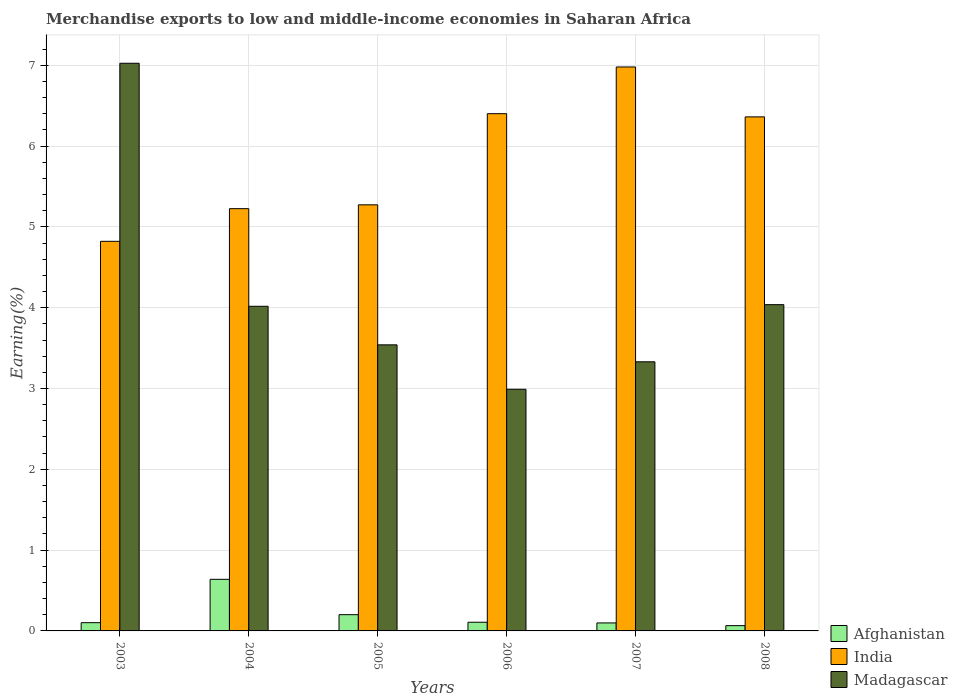How many different coloured bars are there?
Ensure brevity in your answer.  3. How many groups of bars are there?
Make the answer very short. 6. How many bars are there on the 2nd tick from the left?
Offer a terse response. 3. What is the label of the 6th group of bars from the left?
Your answer should be compact. 2008. What is the percentage of amount earned from merchandise exports in Afghanistan in 2007?
Provide a succinct answer. 0.1. Across all years, what is the maximum percentage of amount earned from merchandise exports in Afghanistan?
Give a very brief answer. 0.64. Across all years, what is the minimum percentage of amount earned from merchandise exports in Afghanistan?
Offer a very short reply. 0.07. In which year was the percentage of amount earned from merchandise exports in India maximum?
Give a very brief answer. 2007. In which year was the percentage of amount earned from merchandise exports in Afghanistan minimum?
Provide a succinct answer. 2008. What is the total percentage of amount earned from merchandise exports in Madagascar in the graph?
Provide a succinct answer. 24.94. What is the difference between the percentage of amount earned from merchandise exports in Madagascar in 2006 and that in 2007?
Offer a terse response. -0.34. What is the difference between the percentage of amount earned from merchandise exports in Madagascar in 2007 and the percentage of amount earned from merchandise exports in Afghanistan in 2004?
Your answer should be compact. 2.69. What is the average percentage of amount earned from merchandise exports in Madagascar per year?
Offer a terse response. 4.16. In the year 2007, what is the difference between the percentage of amount earned from merchandise exports in India and percentage of amount earned from merchandise exports in Madagascar?
Keep it short and to the point. 3.65. In how many years, is the percentage of amount earned from merchandise exports in Afghanistan greater than 6 %?
Make the answer very short. 0. What is the ratio of the percentage of amount earned from merchandise exports in Afghanistan in 2004 to that in 2008?
Make the answer very short. 9.75. Is the percentage of amount earned from merchandise exports in India in 2007 less than that in 2008?
Your response must be concise. No. Is the difference between the percentage of amount earned from merchandise exports in India in 2003 and 2007 greater than the difference between the percentage of amount earned from merchandise exports in Madagascar in 2003 and 2007?
Make the answer very short. No. What is the difference between the highest and the second highest percentage of amount earned from merchandise exports in Madagascar?
Your response must be concise. 2.99. What is the difference between the highest and the lowest percentage of amount earned from merchandise exports in India?
Provide a short and direct response. 2.16. In how many years, is the percentage of amount earned from merchandise exports in Madagascar greater than the average percentage of amount earned from merchandise exports in Madagascar taken over all years?
Offer a very short reply. 1. How many bars are there?
Provide a short and direct response. 18. Are all the bars in the graph horizontal?
Ensure brevity in your answer.  No. How many legend labels are there?
Make the answer very short. 3. How are the legend labels stacked?
Keep it short and to the point. Vertical. What is the title of the graph?
Your response must be concise. Merchandise exports to low and middle-income economies in Saharan Africa. Does "Tonga" appear as one of the legend labels in the graph?
Offer a very short reply. No. What is the label or title of the Y-axis?
Your answer should be very brief. Earning(%). What is the Earning(%) in Afghanistan in 2003?
Give a very brief answer. 0.1. What is the Earning(%) of India in 2003?
Provide a short and direct response. 4.82. What is the Earning(%) of Madagascar in 2003?
Make the answer very short. 7.02. What is the Earning(%) in Afghanistan in 2004?
Your response must be concise. 0.64. What is the Earning(%) of India in 2004?
Provide a succinct answer. 5.23. What is the Earning(%) in Madagascar in 2004?
Make the answer very short. 4.02. What is the Earning(%) in Afghanistan in 2005?
Offer a very short reply. 0.2. What is the Earning(%) of India in 2005?
Provide a short and direct response. 5.27. What is the Earning(%) of Madagascar in 2005?
Your answer should be compact. 3.54. What is the Earning(%) of Afghanistan in 2006?
Make the answer very short. 0.11. What is the Earning(%) in India in 2006?
Offer a very short reply. 6.4. What is the Earning(%) in Madagascar in 2006?
Keep it short and to the point. 2.99. What is the Earning(%) in Afghanistan in 2007?
Offer a terse response. 0.1. What is the Earning(%) of India in 2007?
Your answer should be compact. 6.98. What is the Earning(%) of Madagascar in 2007?
Your answer should be compact. 3.33. What is the Earning(%) in Afghanistan in 2008?
Offer a terse response. 0.07. What is the Earning(%) of India in 2008?
Offer a very short reply. 6.36. What is the Earning(%) in Madagascar in 2008?
Your response must be concise. 4.04. Across all years, what is the maximum Earning(%) in Afghanistan?
Make the answer very short. 0.64. Across all years, what is the maximum Earning(%) of India?
Keep it short and to the point. 6.98. Across all years, what is the maximum Earning(%) in Madagascar?
Offer a very short reply. 7.02. Across all years, what is the minimum Earning(%) of Afghanistan?
Keep it short and to the point. 0.07. Across all years, what is the minimum Earning(%) in India?
Make the answer very short. 4.82. Across all years, what is the minimum Earning(%) of Madagascar?
Your response must be concise. 2.99. What is the total Earning(%) of Afghanistan in the graph?
Your answer should be very brief. 1.21. What is the total Earning(%) of India in the graph?
Give a very brief answer. 35.06. What is the total Earning(%) in Madagascar in the graph?
Your response must be concise. 24.94. What is the difference between the Earning(%) in Afghanistan in 2003 and that in 2004?
Offer a very short reply. -0.54. What is the difference between the Earning(%) in India in 2003 and that in 2004?
Your response must be concise. -0.4. What is the difference between the Earning(%) in Madagascar in 2003 and that in 2004?
Provide a succinct answer. 3.01. What is the difference between the Earning(%) of Afghanistan in 2003 and that in 2005?
Provide a short and direct response. -0.1. What is the difference between the Earning(%) of India in 2003 and that in 2005?
Make the answer very short. -0.45. What is the difference between the Earning(%) of Madagascar in 2003 and that in 2005?
Offer a very short reply. 3.48. What is the difference between the Earning(%) of Afghanistan in 2003 and that in 2006?
Ensure brevity in your answer.  -0.01. What is the difference between the Earning(%) of India in 2003 and that in 2006?
Give a very brief answer. -1.58. What is the difference between the Earning(%) of Madagascar in 2003 and that in 2006?
Your response must be concise. 4.03. What is the difference between the Earning(%) of Afghanistan in 2003 and that in 2007?
Provide a succinct answer. 0. What is the difference between the Earning(%) in India in 2003 and that in 2007?
Your response must be concise. -2.16. What is the difference between the Earning(%) of Madagascar in 2003 and that in 2007?
Make the answer very short. 3.69. What is the difference between the Earning(%) of Afghanistan in 2003 and that in 2008?
Offer a very short reply. 0.04. What is the difference between the Earning(%) of India in 2003 and that in 2008?
Your answer should be compact. -1.54. What is the difference between the Earning(%) of Madagascar in 2003 and that in 2008?
Provide a short and direct response. 2.99. What is the difference between the Earning(%) in Afghanistan in 2004 and that in 2005?
Your response must be concise. 0.44. What is the difference between the Earning(%) in India in 2004 and that in 2005?
Provide a short and direct response. -0.05. What is the difference between the Earning(%) in Madagascar in 2004 and that in 2005?
Ensure brevity in your answer.  0.48. What is the difference between the Earning(%) of Afghanistan in 2004 and that in 2006?
Offer a terse response. 0.53. What is the difference between the Earning(%) in India in 2004 and that in 2006?
Your response must be concise. -1.18. What is the difference between the Earning(%) in Madagascar in 2004 and that in 2006?
Provide a succinct answer. 1.03. What is the difference between the Earning(%) of Afghanistan in 2004 and that in 2007?
Your answer should be compact. 0.54. What is the difference between the Earning(%) of India in 2004 and that in 2007?
Offer a terse response. -1.75. What is the difference between the Earning(%) of Madagascar in 2004 and that in 2007?
Provide a succinct answer. 0.69. What is the difference between the Earning(%) of Afghanistan in 2004 and that in 2008?
Your answer should be compact. 0.57. What is the difference between the Earning(%) in India in 2004 and that in 2008?
Provide a short and direct response. -1.14. What is the difference between the Earning(%) in Madagascar in 2004 and that in 2008?
Your answer should be compact. -0.02. What is the difference between the Earning(%) in Afghanistan in 2005 and that in 2006?
Make the answer very short. 0.09. What is the difference between the Earning(%) of India in 2005 and that in 2006?
Make the answer very short. -1.13. What is the difference between the Earning(%) in Madagascar in 2005 and that in 2006?
Your response must be concise. 0.55. What is the difference between the Earning(%) in Afghanistan in 2005 and that in 2007?
Your answer should be compact. 0.1. What is the difference between the Earning(%) in India in 2005 and that in 2007?
Provide a succinct answer. -1.71. What is the difference between the Earning(%) of Madagascar in 2005 and that in 2007?
Provide a short and direct response. 0.21. What is the difference between the Earning(%) in Afghanistan in 2005 and that in 2008?
Your response must be concise. 0.14. What is the difference between the Earning(%) of India in 2005 and that in 2008?
Your response must be concise. -1.09. What is the difference between the Earning(%) of Madagascar in 2005 and that in 2008?
Give a very brief answer. -0.5. What is the difference between the Earning(%) in Afghanistan in 2006 and that in 2007?
Provide a short and direct response. 0.01. What is the difference between the Earning(%) in India in 2006 and that in 2007?
Offer a terse response. -0.58. What is the difference between the Earning(%) in Madagascar in 2006 and that in 2007?
Offer a very short reply. -0.34. What is the difference between the Earning(%) in Afghanistan in 2006 and that in 2008?
Ensure brevity in your answer.  0.04. What is the difference between the Earning(%) in India in 2006 and that in 2008?
Offer a terse response. 0.04. What is the difference between the Earning(%) of Madagascar in 2006 and that in 2008?
Keep it short and to the point. -1.05. What is the difference between the Earning(%) of Afghanistan in 2007 and that in 2008?
Offer a terse response. 0.03. What is the difference between the Earning(%) in India in 2007 and that in 2008?
Give a very brief answer. 0.62. What is the difference between the Earning(%) in Madagascar in 2007 and that in 2008?
Provide a succinct answer. -0.71. What is the difference between the Earning(%) of Afghanistan in 2003 and the Earning(%) of India in 2004?
Ensure brevity in your answer.  -5.12. What is the difference between the Earning(%) of Afghanistan in 2003 and the Earning(%) of Madagascar in 2004?
Your answer should be very brief. -3.92. What is the difference between the Earning(%) in India in 2003 and the Earning(%) in Madagascar in 2004?
Offer a very short reply. 0.8. What is the difference between the Earning(%) in Afghanistan in 2003 and the Earning(%) in India in 2005?
Offer a very short reply. -5.17. What is the difference between the Earning(%) in Afghanistan in 2003 and the Earning(%) in Madagascar in 2005?
Make the answer very short. -3.44. What is the difference between the Earning(%) of India in 2003 and the Earning(%) of Madagascar in 2005?
Offer a terse response. 1.28. What is the difference between the Earning(%) in Afghanistan in 2003 and the Earning(%) in India in 2006?
Provide a succinct answer. -6.3. What is the difference between the Earning(%) in Afghanistan in 2003 and the Earning(%) in Madagascar in 2006?
Ensure brevity in your answer.  -2.89. What is the difference between the Earning(%) in India in 2003 and the Earning(%) in Madagascar in 2006?
Offer a very short reply. 1.83. What is the difference between the Earning(%) in Afghanistan in 2003 and the Earning(%) in India in 2007?
Your answer should be compact. -6.88. What is the difference between the Earning(%) of Afghanistan in 2003 and the Earning(%) of Madagascar in 2007?
Provide a short and direct response. -3.23. What is the difference between the Earning(%) in India in 2003 and the Earning(%) in Madagascar in 2007?
Your response must be concise. 1.49. What is the difference between the Earning(%) in Afghanistan in 2003 and the Earning(%) in India in 2008?
Provide a short and direct response. -6.26. What is the difference between the Earning(%) of Afghanistan in 2003 and the Earning(%) of Madagascar in 2008?
Offer a terse response. -3.94. What is the difference between the Earning(%) of India in 2003 and the Earning(%) of Madagascar in 2008?
Keep it short and to the point. 0.78. What is the difference between the Earning(%) of Afghanistan in 2004 and the Earning(%) of India in 2005?
Give a very brief answer. -4.63. What is the difference between the Earning(%) in Afghanistan in 2004 and the Earning(%) in Madagascar in 2005?
Your answer should be compact. -2.9. What is the difference between the Earning(%) in India in 2004 and the Earning(%) in Madagascar in 2005?
Make the answer very short. 1.69. What is the difference between the Earning(%) in Afghanistan in 2004 and the Earning(%) in India in 2006?
Your response must be concise. -5.76. What is the difference between the Earning(%) in Afghanistan in 2004 and the Earning(%) in Madagascar in 2006?
Make the answer very short. -2.35. What is the difference between the Earning(%) in India in 2004 and the Earning(%) in Madagascar in 2006?
Make the answer very short. 2.23. What is the difference between the Earning(%) in Afghanistan in 2004 and the Earning(%) in India in 2007?
Make the answer very short. -6.34. What is the difference between the Earning(%) of Afghanistan in 2004 and the Earning(%) of Madagascar in 2007?
Offer a terse response. -2.69. What is the difference between the Earning(%) in India in 2004 and the Earning(%) in Madagascar in 2007?
Make the answer very short. 1.89. What is the difference between the Earning(%) of Afghanistan in 2004 and the Earning(%) of India in 2008?
Give a very brief answer. -5.72. What is the difference between the Earning(%) of Afghanistan in 2004 and the Earning(%) of Madagascar in 2008?
Your response must be concise. -3.4. What is the difference between the Earning(%) of India in 2004 and the Earning(%) of Madagascar in 2008?
Provide a succinct answer. 1.19. What is the difference between the Earning(%) of Afghanistan in 2005 and the Earning(%) of India in 2006?
Give a very brief answer. -6.2. What is the difference between the Earning(%) of Afghanistan in 2005 and the Earning(%) of Madagascar in 2006?
Keep it short and to the point. -2.79. What is the difference between the Earning(%) of India in 2005 and the Earning(%) of Madagascar in 2006?
Provide a succinct answer. 2.28. What is the difference between the Earning(%) in Afghanistan in 2005 and the Earning(%) in India in 2007?
Provide a succinct answer. -6.78. What is the difference between the Earning(%) of Afghanistan in 2005 and the Earning(%) of Madagascar in 2007?
Provide a short and direct response. -3.13. What is the difference between the Earning(%) of India in 2005 and the Earning(%) of Madagascar in 2007?
Offer a very short reply. 1.94. What is the difference between the Earning(%) of Afghanistan in 2005 and the Earning(%) of India in 2008?
Make the answer very short. -6.16. What is the difference between the Earning(%) in Afghanistan in 2005 and the Earning(%) in Madagascar in 2008?
Make the answer very short. -3.84. What is the difference between the Earning(%) in India in 2005 and the Earning(%) in Madagascar in 2008?
Provide a succinct answer. 1.24. What is the difference between the Earning(%) of Afghanistan in 2006 and the Earning(%) of India in 2007?
Your answer should be very brief. -6.87. What is the difference between the Earning(%) of Afghanistan in 2006 and the Earning(%) of Madagascar in 2007?
Provide a short and direct response. -3.22. What is the difference between the Earning(%) in India in 2006 and the Earning(%) in Madagascar in 2007?
Your answer should be very brief. 3.07. What is the difference between the Earning(%) in Afghanistan in 2006 and the Earning(%) in India in 2008?
Keep it short and to the point. -6.25. What is the difference between the Earning(%) in Afghanistan in 2006 and the Earning(%) in Madagascar in 2008?
Ensure brevity in your answer.  -3.93. What is the difference between the Earning(%) in India in 2006 and the Earning(%) in Madagascar in 2008?
Keep it short and to the point. 2.36. What is the difference between the Earning(%) in Afghanistan in 2007 and the Earning(%) in India in 2008?
Your response must be concise. -6.26. What is the difference between the Earning(%) in Afghanistan in 2007 and the Earning(%) in Madagascar in 2008?
Keep it short and to the point. -3.94. What is the difference between the Earning(%) in India in 2007 and the Earning(%) in Madagascar in 2008?
Ensure brevity in your answer.  2.94. What is the average Earning(%) in Afghanistan per year?
Your response must be concise. 0.2. What is the average Earning(%) in India per year?
Your answer should be very brief. 5.84. What is the average Earning(%) of Madagascar per year?
Provide a short and direct response. 4.16. In the year 2003, what is the difference between the Earning(%) in Afghanistan and Earning(%) in India?
Provide a short and direct response. -4.72. In the year 2003, what is the difference between the Earning(%) of Afghanistan and Earning(%) of Madagascar?
Your answer should be very brief. -6.92. In the year 2003, what is the difference between the Earning(%) of India and Earning(%) of Madagascar?
Your response must be concise. -2.2. In the year 2004, what is the difference between the Earning(%) of Afghanistan and Earning(%) of India?
Your response must be concise. -4.59. In the year 2004, what is the difference between the Earning(%) of Afghanistan and Earning(%) of Madagascar?
Provide a succinct answer. -3.38. In the year 2004, what is the difference between the Earning(%) in India and Earning(%) in Madagascar?
Your response must be concise. 1.21. In the year 2005, what is the difference between the Earning(%) of Afghanistan and Earning(%) of India?
Your answer should be very brief. -5.07. In the year 2005, what is the difference between the Earning(%) in Afghanistan and Earning(%) in Madagascar?
Ensure brevity in your answer.  -3.34. In the year 2005, what is the difference between the Earning(%) in India and Earning(%) in Madagascar?
Offer a very short reply. 1.73. In the year 2006, what is the difference between the Earning(%) of Afghanistan and Earning(%) of India?
Make the answer very short. -6.29. In the year 2006, what is the difference between the Earning(%) of Afghanistan and Earning(%) of Madagascar?
Make the answer very short. -2.88. In the year 2006, what is the difference between the Earning(%) of India and Earning(%) of Madagascar?
Keep it short and to the point. 3.41. In the year 2007, what is the difference between the Earning(%) of Afghanistan and Earning(%) of India?
Offer a very short reply. -6.88. In the year 2007, what is the difference between the Earning(%) of Afghanistan and Earning(%) of Madagascar?
Give a very brief answer. -3.23. In the year 2007, what is the difference between the Earning(%) of India and Earning(%) of Madagascar?
Give a very brief answer. 3.65. In the year 2008, what is the difference between the Earning(%) of Afghanistan and Earning(%) of India?
Your answer should be compact. -6.3. In the year 2008, what is the difference between the Earning(%) in Afghanistan and Earning(%) in Madagascar?
Your response must be concise. -3.97. In the year 2008, what is the difference between the Earning(%) in India and Earning(%) in Madagascar?
Offer a terse response. 2.32. What is the ratio of the Earning(%) in Afghanistan in 2003 to that in 2004?
Give a very brief answer. 0.16. What is the ratio of the Earning(%) of India in 2003 to that in 2004?
Provide a short and direct response. 0.92. What is the ratio of the Earning(%) of Madagascar in 2003 to that in 2004?
Your answer should be very brief. 1.75. What is the ratio of the Earning(%) in Afghanistan in 2003 to that in 2005?
Provide a short and direct response. 0.51. What is the ratio of the Earning(%) of India in 2003 to that in 2005?
Your response must be concise. 0.91. What is the ratio of the Earning(%) in Madagascar in 2003 to that in 2005?
Your answer should be very brief. 1.98. What is the ratio of the Earning(%) of Afghanistan in 2003 to that in 2006?
Ensure brevity in your answer.  0.95. What is the ratio of the Earning(%) of India in 2003 to that in 2006?
Your answer should be very brief. 0.75. What is the ratio of the Earning(%) of Madagascar in 2003 to that in 2006?
Provide a succinct answer. 2.35. What is the ratio of the Earning(%) in India in 2003 to that in 2007?
Offer a very short reply. 0.69. What is the ratio of the Earning(%) of Madagascar in 2003 to that in 2007?
Give a very brief answer. 2.11. What is the ratio of the Earning(%) in Afghanistan in 2003 to that in 2008?
Your response must be concise. 1.56. What is the ratio of the Earning(%) in India in 2003 to that in 2008?
Offer a very short reply. 0.76. What is the ratio of the Earning(%) of Madagascar in 2003 to that in 2008?
Your answer should be compact. 1.74. What is the ratio of the Earning(%) in Afghanistan in 2004 to that in 2005?
Offer a terse response. 3.18. What is the ratio of the Earning(%) of Madagascar in 2004 to that in 2005?
Keep it short and to the point. 1.13. What is the ratio of the Earning(%) of Afghanistan in 2004 to that in 2006?
Provide a succinct answer. 5.94. What is the ratio of the Earning(%) of India in 2004 to that in 2006?
Your answer should be compact. 0.82. What is the ratio of the Earning(%) of Madagascar in 2004 to that in 2006?
Provide a succinct answer. 1.34. What is the ratio of the Earning(%) in Afghanistan in 2004 to that in 2007?
Offer a terse response. 6.45. What is the ratio of the Earning(%) of India in 2004 to that in 2007?
Offer a very short reply. 0.75. What is the ratio of the Earning(%) of Madagascar in 2004 to that in 2007?
Offer a very short reply. 1.21. What is the ratio of the Earning(%) in Afghanistan in 2004 to that in 2008?
Ensure brevity in your answer.  9.75. What is the ratio of the Earning(%) of India in 2004 to that in 2008?
Offer a terse response. 0.82. What is the ratio of the Earning(%) of Afghanistan in 2005 to that in 2006?
Offer a very short reply. 1.87. What is the ratio of the Earning(%) in India in 2005 to that in 2006?
Ensure brevity in your answer.  0.82. What is the ratio of the Earning(%) of Madagascar in 2005 to that in 2006?
Provide a succinct answer. 1.18. What is the ratio of the Earning(%) in Afghanistan in 2005 to that in 2007?
Offer a very short reply. 2.03. What is the ratio of the Earning(%) of India in 2005 to that in 2007?
Offer a terse response. 0.76. What is the ratio of the Earning(%) of Madagascar in 2005 to that in 2007?
Provide a short and direct response. 1.06. What is the ratio of the Earning(%) of Afghanistan in 2005 to that in 2008?
Your response must be concise. 3.07. What is the ratio of the Earning(%) of India in 2005 to that in 2008?
Your answer should be compact. 0.83. What is the ratio of the Earning(%) in Madagascar in 2005 to that in 2008?
Keep it short and to the point. 0.88. What is the ratio of the Earning(%) of Afghanistan in 2006 to that in 2007?
Provide a short and direct response. 1.09. What is the ratio of the Earning(%) in India in 2006 to that in 2007?
Your answer should be compact. 0.92. What is the ratio of the Earning(%) in Madagascar in 2006 to that in 2007?
Provide a short and direct response. 0.9. What is the ratio of the Earning(%) of Afghanistan in 2006 to that in 2008?
Your answer should be very brief. 1.64. What is the ratio of the Earning(%) of Madagascar in 2006 to that in 2008?
Provide a succinct answer. 0.74. What is the ratio of the Earning(%) of Afghanistan in 2007 to that in 2008?
Give a very brief answer. 1.51. What is the ratio of the Earning(%) in India in 2007 to that in 2008?
Your answer should be compact. 1.1. What is the ratio of the Earning(%) in Madagascar in 2007 to that in 2008?
Provide a succinct answer. 0.82. What is the difference between the highest and the second highest Earning(%) in Afghanistan?
Your answer should be very brief. 0.44. What is the difference between the highest and the second highest Earning(%) of India?
Ensure brevity in your answer.  0.58. What is the difference between the highest and the second highest Earning(%) of Madagascar?
Ensure brevity in your answer.  2.99. What is the difference between the highest and the lowest Earning(%) in Afghanistan?
Give a very brief answer. 0.57. What is the difference between the highest and the lowest Earning(%) of India?
Keep it short and to the point. 2.16. What is the difference between the highest and the lowest Earning(%) of Madagascar?
Your answer should be very brief. 4.03. 